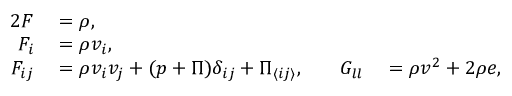Convert formula to latex. <formula><loc_0><loc_0><loc_500><loc_500>\begin{array} { r l r l } { { 2 } F } & = \rho , } & { \quad } & \quad } \\ { F _ { i } } & = \rho v _ { i } , } & { \quad } & \quad } \\ { F _ { i j } } & = \rho v _ { i } v _ { j } + ( p + \Pi ) \delta _ { i j } + \Pi _ { \langle i j \rangle } , } & { \quad G _ { l l } } & = \rho v ^ { 2 } + 2 \rho e , } \end{array}</formula> 